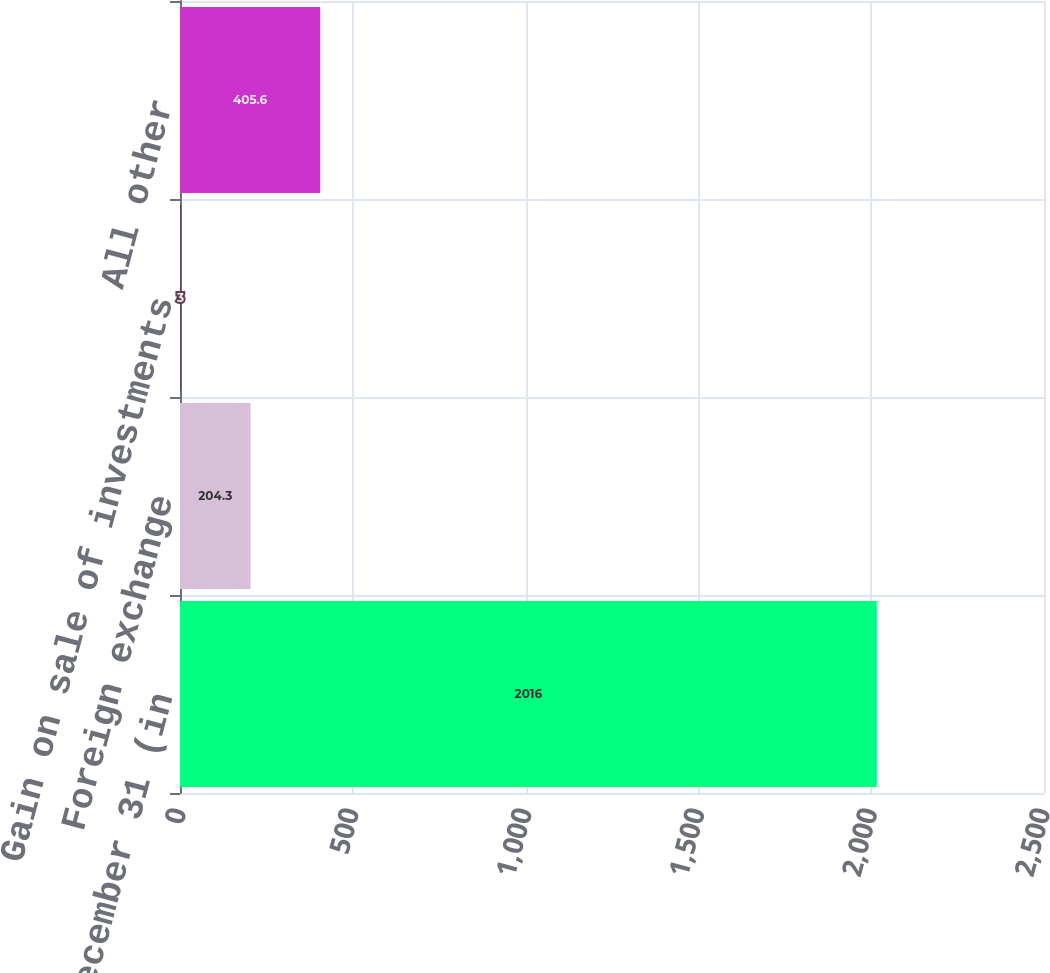Convert chart. <chart><loc_0><loc_0><loc_500><loc_500><bar_chart><fcel>years ended December 31 (in<fcel>Foreign exchange<fcel>Gain on sale of investments<fcel>All other<nl><fcel>2016<fcel>204.3<fcel>3<fcel>405.6<nl></chart> 